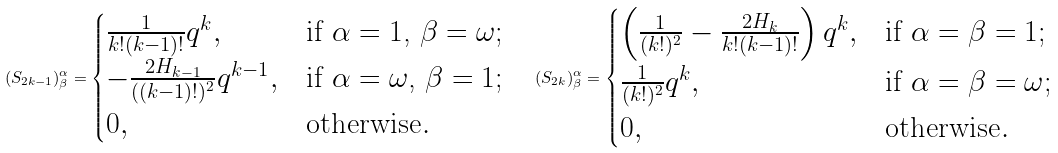<formula> <loc_0><loc_0><loc_500><loc_500>( S _ { 2 k - 1 } ) ^ { \alpha } _ { \beta } = \begin{cases} \frac { 1 } { k ! ( k - 1 ) ! } q ^ { k } , & \text {if $\alpha=1$, $\beta=\omega$} ; \\ - \frac { 2 H _ { k - 1 } } { ( ( k - 1 ) ! ) ^ { 2 } } q ^ { k - 1 } , & \text {if $\alpha=\omega$, $\beta=1$} ; \\ 0 , & \text {otherwise} . \end{cases} \quad ( S _ { 2 k } ) ^ { \alpha } _ { \beta } = \begin{cases} \left ( \frac { 1 } { ( k ! ) ^ { 2 } } - \frac { 2 H _ { k } } { k ! ( k - 1 ) ! } \right ) q ^ { k } , & \text {if $\alpha=\beta=1$} ; \\ \frac { 1 } { ( k ! ) ^ { 2 } } q ^ { k } , & \text {if $\alpha=\beta=\omega$} ; \\ 0 , & \text {otherwise} . \end{cases}</formula> 